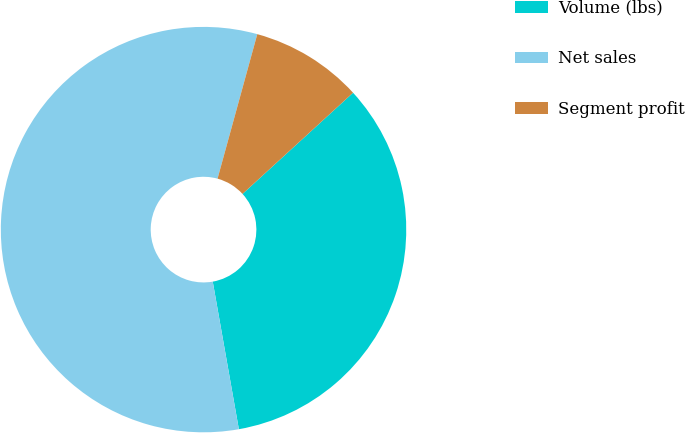Convert chart to OTSL. <chart><loc_0><loc_0><loc_500><loc_500><pie_chart><fcel>Volume (lbs)<fcel>Net sales<fcel>Segment profit<nl><fcel>34.01%<fcel>57.06%<fcel>8.93%<nl></chart> 